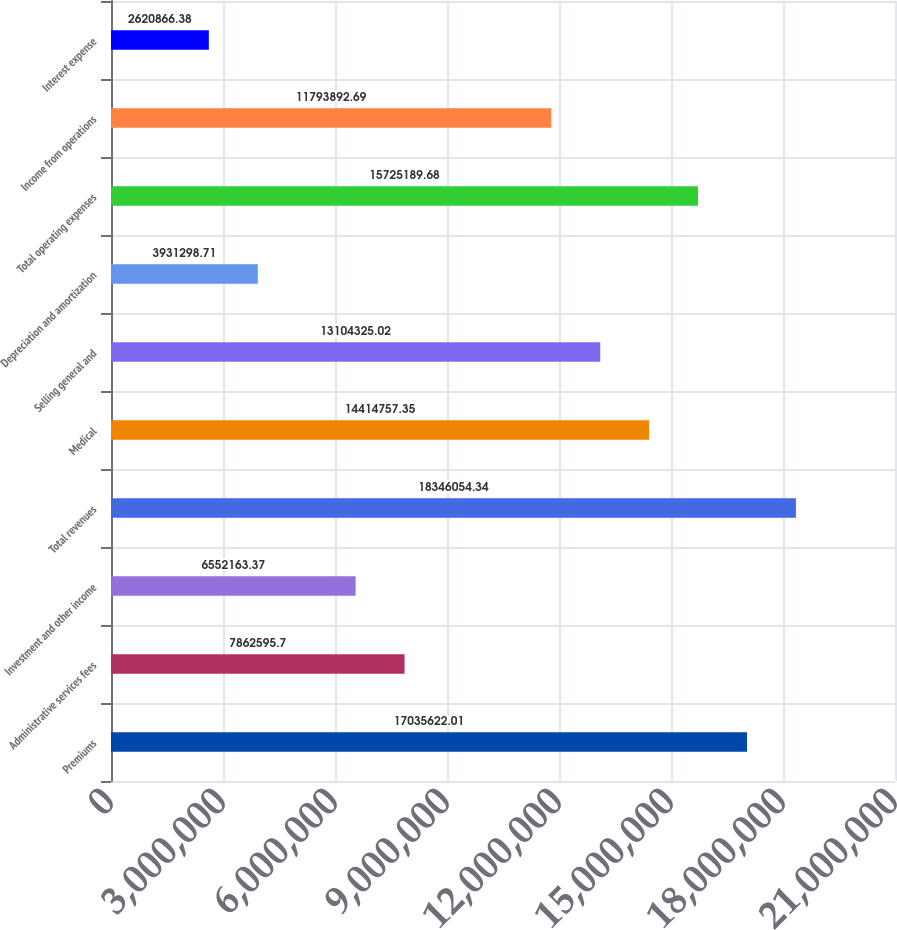<chart> <loc_0><loc_0><loc_500><loc_500><bar_chart><fcel>Premiums<fcel>Administrative services fees<fcel>Investment and other income<fcel>Total revenues<fcel>Medical<fcel>Selling general and<fcel>Depreciation and amortization<fcel>Total operating expenses<fcel>Income from operations<fcel>Interest expense<nl><fcel>1.70356e+07<fcel>7.8626e+06<fcel>6.55216e+06<fcel>1.83461e+07<fcel>1.44148e+07<fcel>1.31043e+07<fcel>3.9313e+06<fcel>1.57252e+07<fcel>1.17939e+07<fcel>2.62087e+06<nl></chart> 